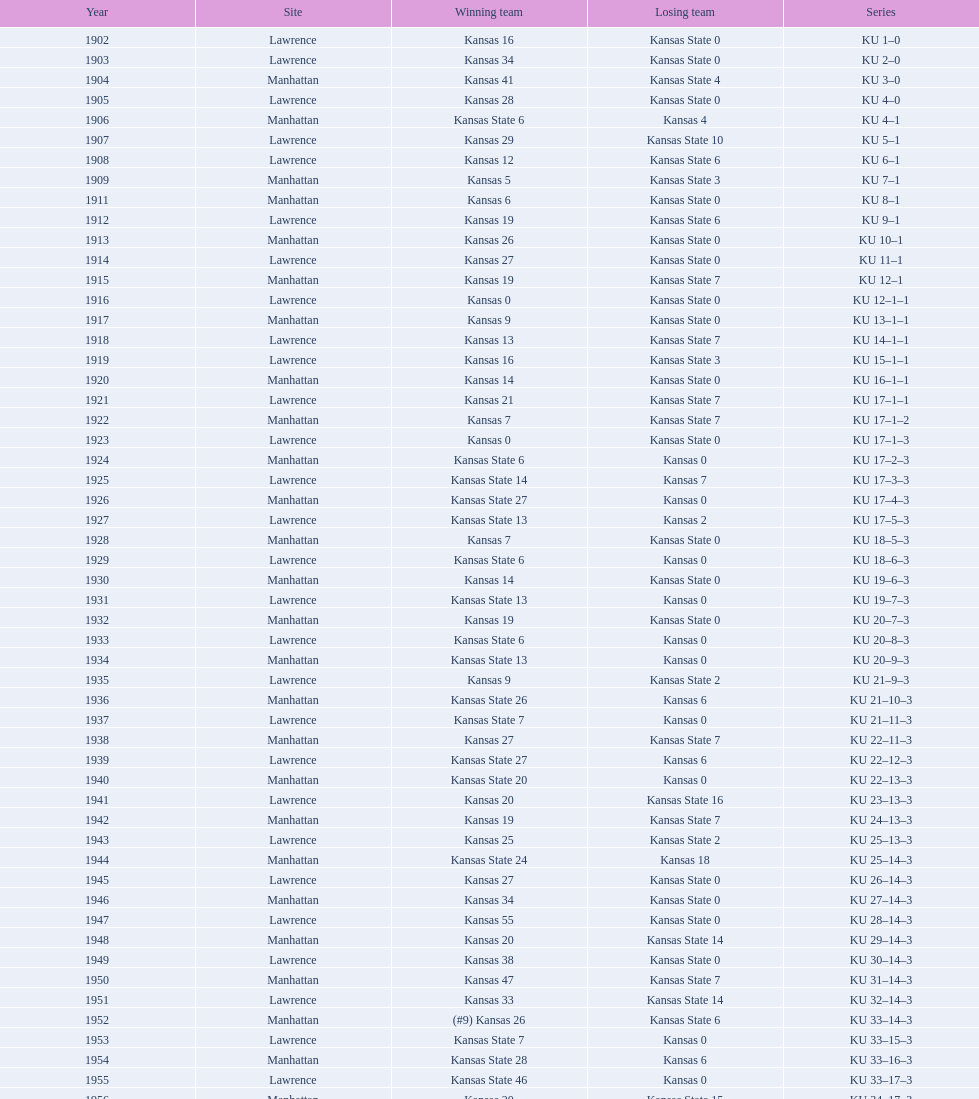In which game did kansas state first secure a win with a double-digit margin? 1926. 